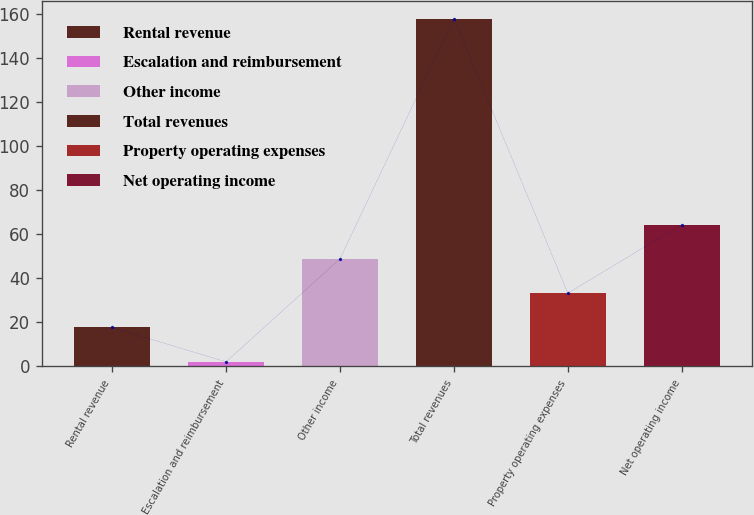Convert chart. <chart><loc_0><loc_0><loc_500><loc_500><bar_chart><fcel>Rental revenue<fcel>Escalation and reimbursement<fcel>Other income<fcel>Total revenues<fcel>Property operating expenses<fcel>Net operating income<nl><fcel>17.68<fcel>2.1<fcel>48.84<fcel>157.9<fcel>33.26<fcel>64.42<nl></chart> 